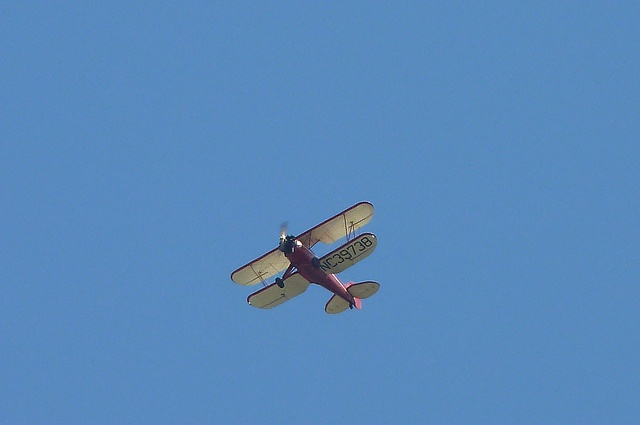Describe the objects in this image and their specific colors. I can see a airplane in gray, black, and darkgray tones in this image. 